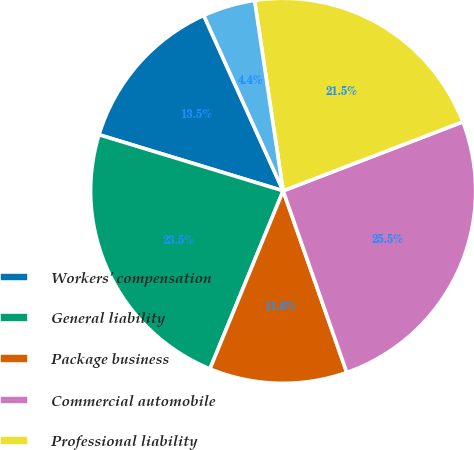Convert chart. <chart><loc_0><loc_0><loc_500><loc_500><pie_chart><fcel>Workers' compensation<fcel>General liability<fcel>Package business<fcel>Commercial automobile<fcel>Professional liability<fcel>Bond<nl><fcel>13.53%<fcel>23.5%<fcel>11.57%<fcel>25.47%<fcel>21.54%<fcel>4.39%<nl></chart> 